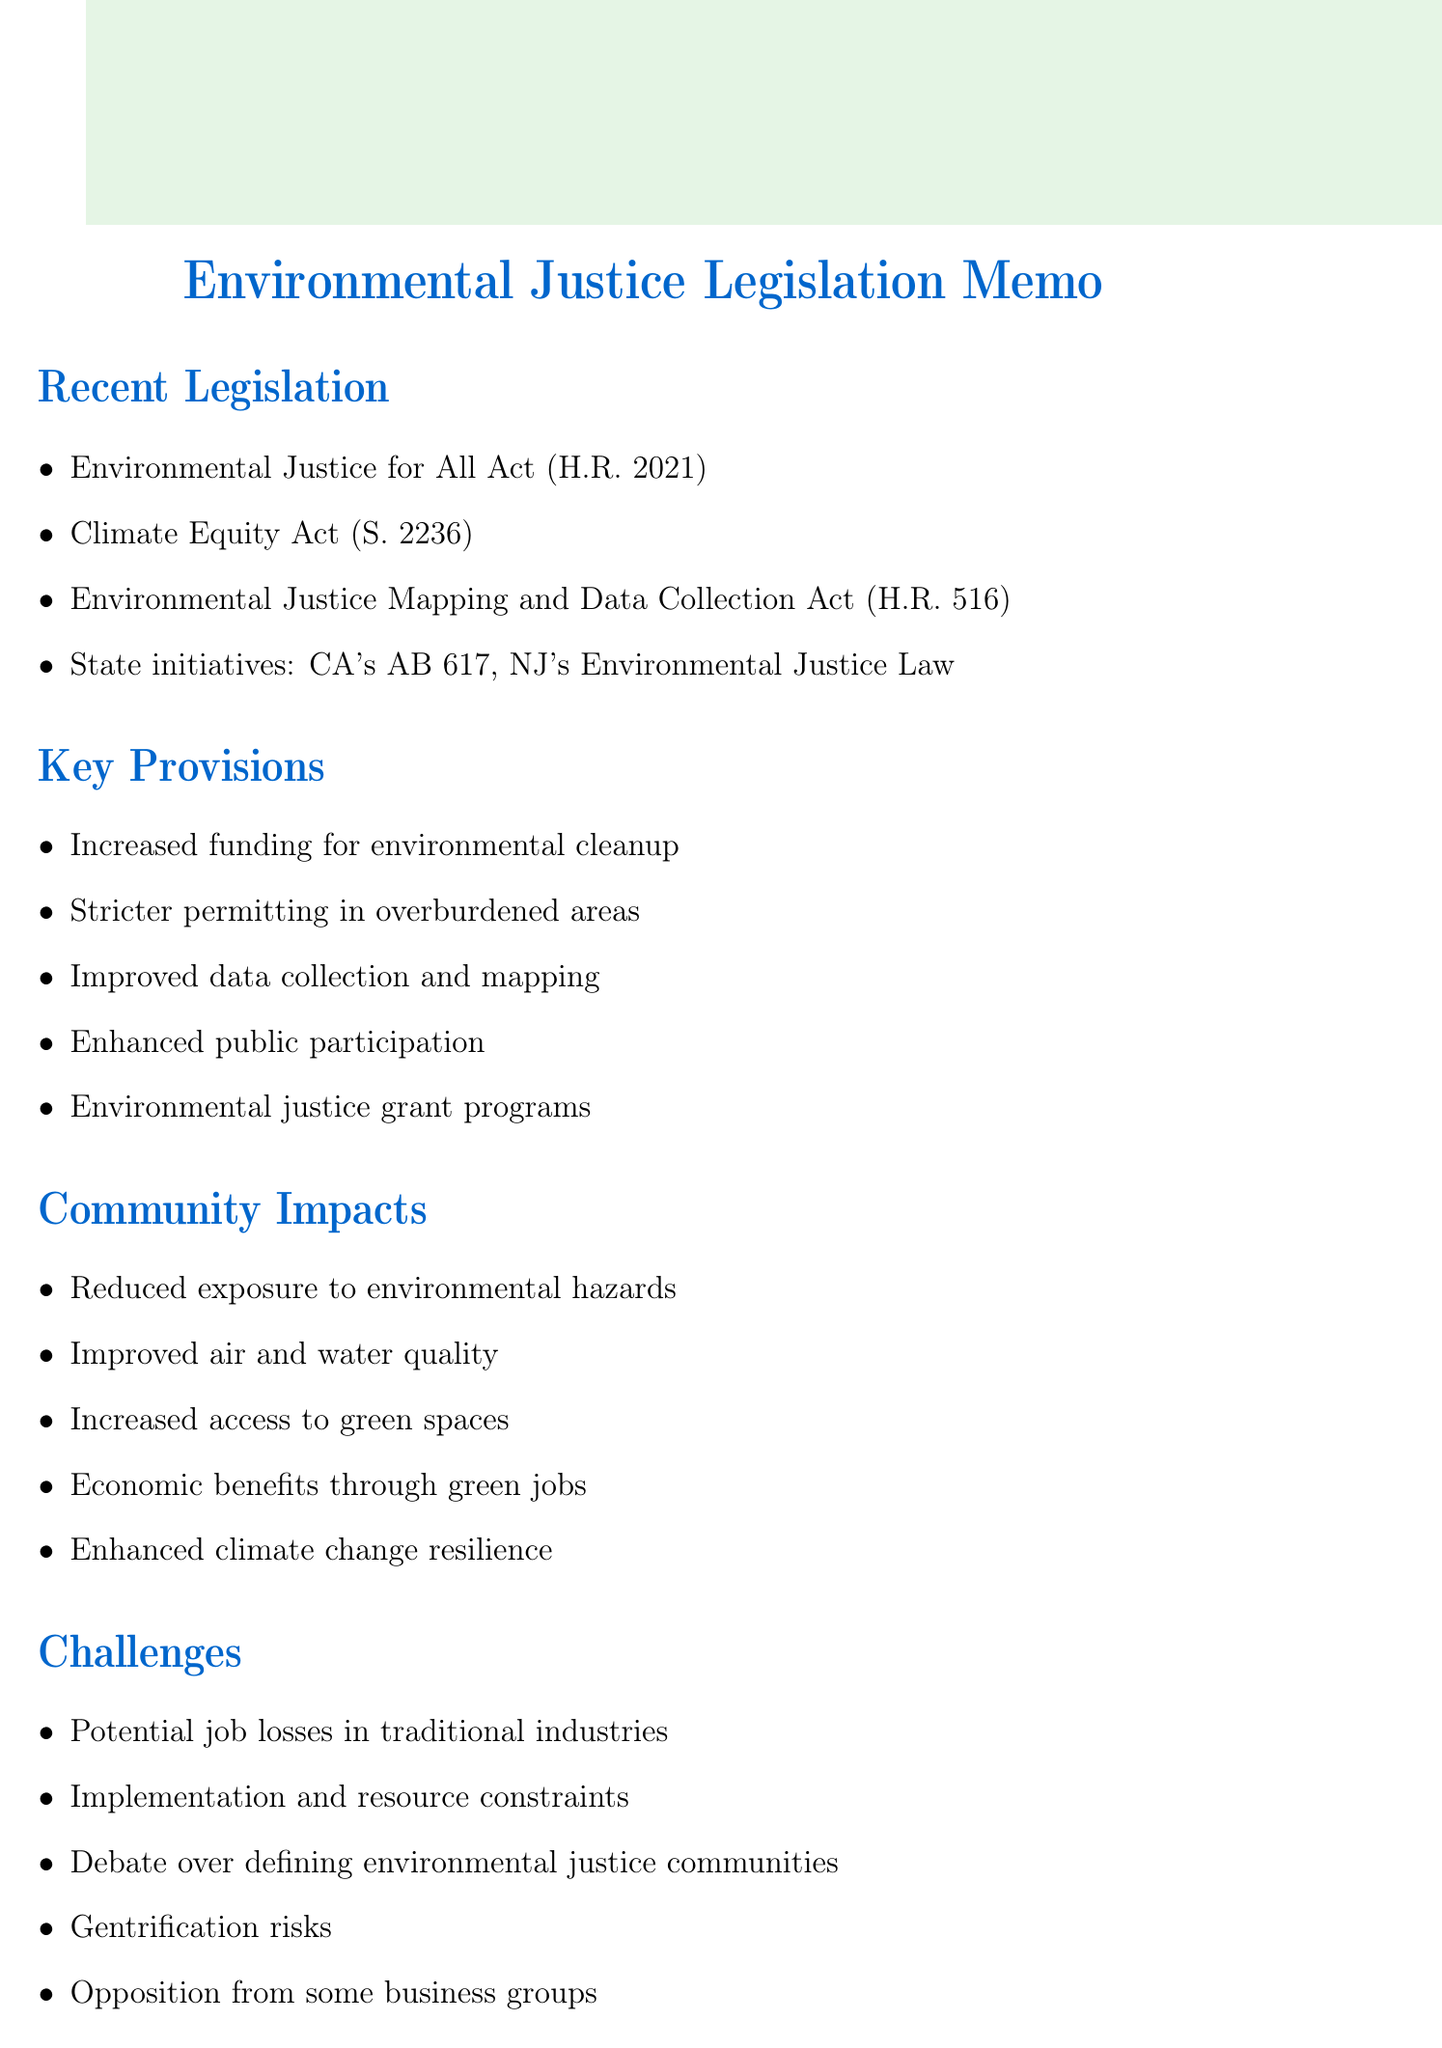What is the title of the proposed federal legislation that focuses on environmental justice? The title of the proposed federal legislation is the Environmental Justice for All Act.
Answer: Environmental Justice for All Act What year was the Climate Equity Act reintroduced? The Climate Equity Act was reintroduced in 2021.
Answer: 2021 What are community-led projects supported by recent legislation? The legislation provides for environmental justice grant programs for community-led projects.
Answer: Environmental justice grant programs Which California initiative is mentioned in the document? The document mentions California's AB 617 as a state-level initiative.
Answer: AB 617 What is one potential impact of the legislation on local communities? One potential impact is improved air and water quality in historically polluted areas.
Answer: Improved air and water quality What challenge might arise from implementation due to limited resources? The challenge is related to implementation constraints due to limited resources and capacity.
Answer: Limited resources and capacity Which case study illustrates reduced emissions? The Port of Los Angeles case study illustrates reduced emissions under AB 617.
Answer: Port of Los Angeles What is one of the next steps outlined for advocacy? One of the next steps is to push for the passage of the Environmental Justice for All Act.
Answer: Push for the Environmental Justice for All Act What debate is noted in the challenges section regarding environmental justice communities? The debate is over the definition and identification of environmental justice communities.
Answer: Definition and identification of environmental justice communities 